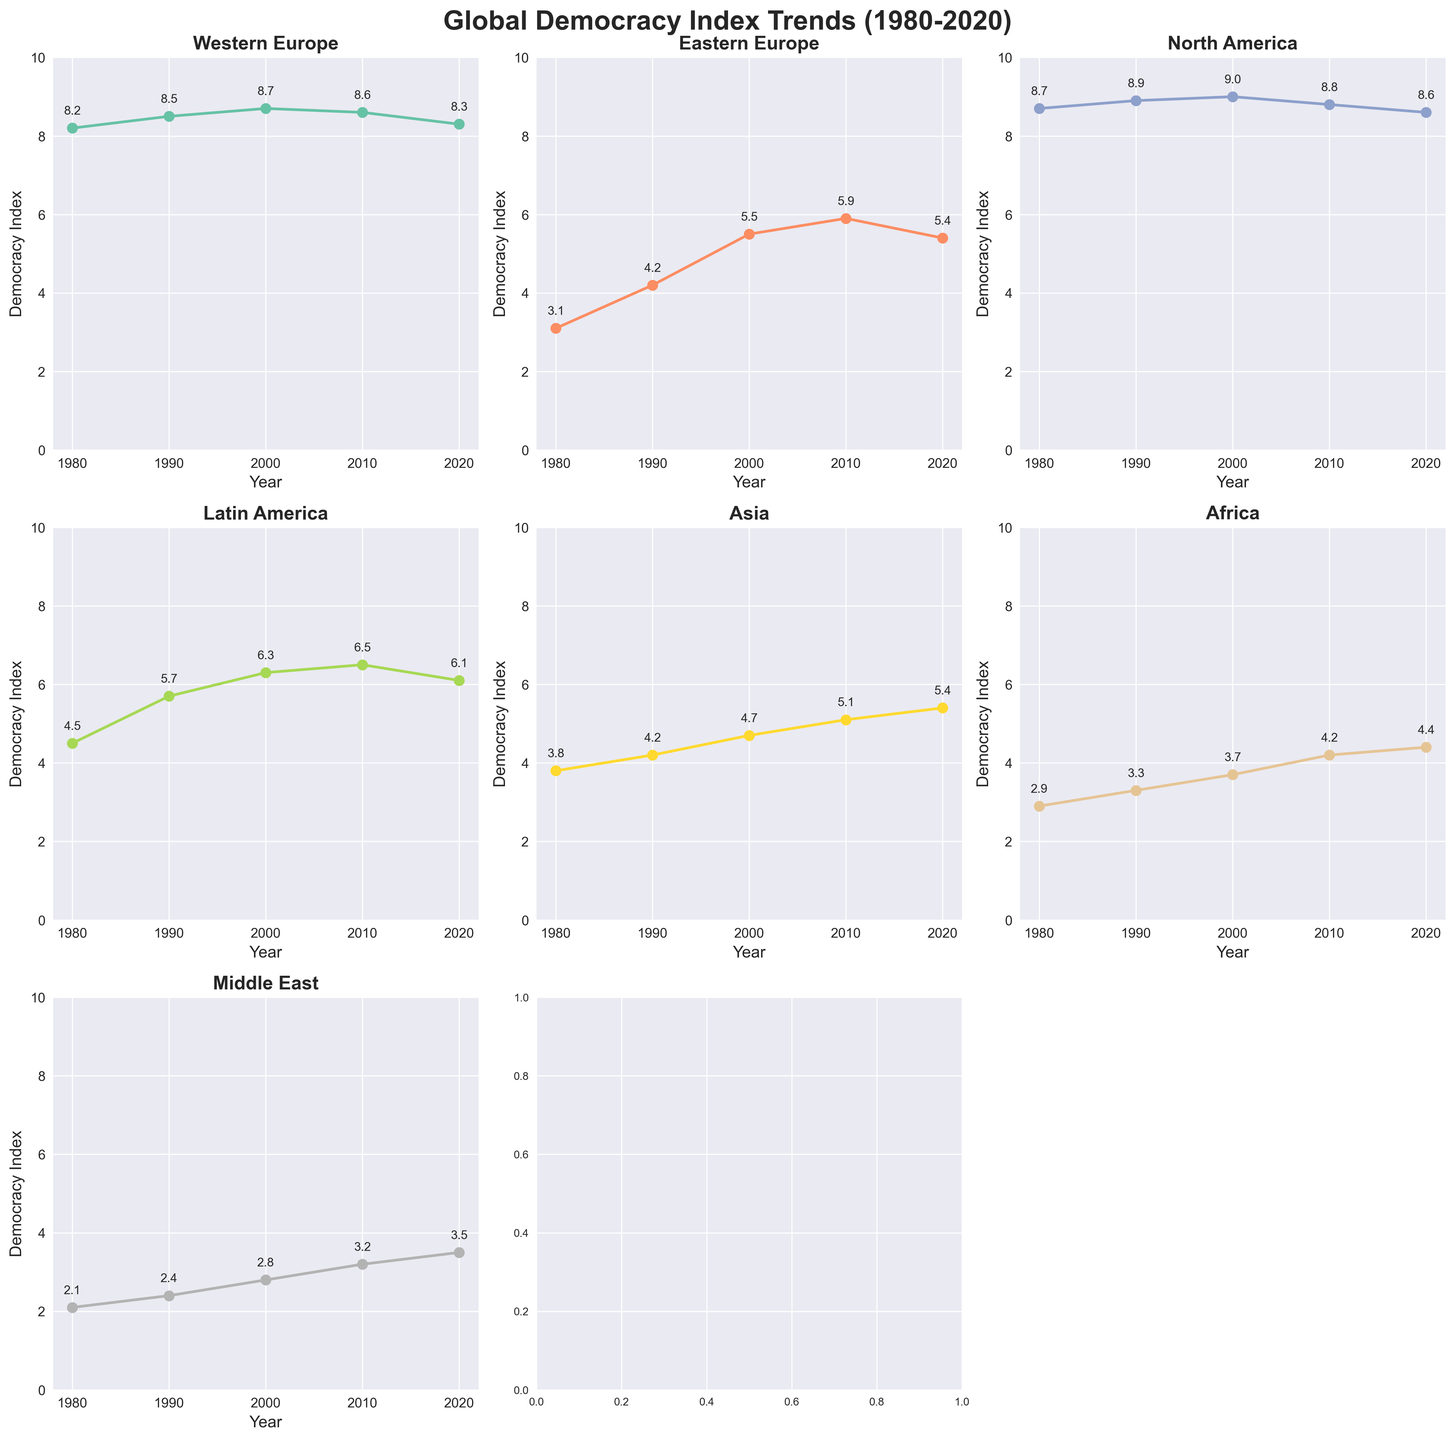what is the title of the figure? The title is displayed at the top of the figure. It reads 'Global Democracy Index Trends (1980-2020)'.
Answer: Global Democracy Index Trends (1980-2020) What is the democracy index for North America in 2000? Locate the subplot for North America and find the value corresponding to the year 2000. The value is annotated on the data point.
Answer: 9.0 Which region had the largest increase in the democracy index from 1980 to 2020? Calculate the difference between the democracy index in 2020 and 1980 for each region. The region with the largest difference is Eastern Europe (5.4 - 3.1 = 2.3).
Answer: Eastern Europe What was the average democracy index for Western Europe from 1980 to 2020? The average is calculated by summing the democracy index values for Western Europe over the years and dividing by the number of years: (8.2 + 8.5 + 8.7 + 8.6 + 8.3) / 5 = 8.46.
Answer: 8.46 Compare the democracy index trend of Asia and Africa between 1980 and 2020. Which region improved more? Calculate the changes in democracy index from 1980 to 2020 for both regions: Asia (5.4 - 3.8 = 1.6) and Africa (4.4 - 2.9 = 1.5). Asia improved more.
Answer: Asia Which regions consistently had a democracy index above 5 from 2000 to 2020? For each region, check the democracy index values from 2000, 2010, and 2020. Western Europe, North America, and Latin America had values above 5 in all these years.
Answer: Western Europe, North America, Latin America In which year did Latin America see the highest democracy index value? Identify the highest value in the Latin America subplot and check the corresponding year. The highest value is 6.5 in 2010.
Answer: 2010 Which region had a steady increase in their democracy index without any decline between 1980 and 2020? Review each region's subplot to identify a consistent upward trend without any dips. Eastern Europe shows a steady increase without decline.
Answer: Eastern Europe What's the difference in the 2020 democracy index between the Middle East and Western Europe? Subtract the 2020 value for the Middle East from the 2020 value for Western Europe: 8.3 - 3.5 = 4.8.
Answer: 4.8 How did the democracy index for the Middle East change from 1980 to 2020? Check the starting and ending values of the Middle East subplot and calculate the difference: 3.5 - 2.1 = 1.4.
Answer: Increased by 1.4 